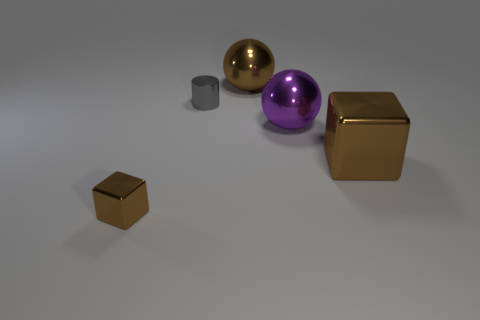Does the brown object left of the gray shiny cylinder have the same material as the large brown object behind the big brown metal block?
Provide a short and direct response. Yes. What is the shape of the big shiny object that is the same color as the large metallic block?
Your answer should be very brief. Sphere. How many brown things are either metal cubes or small cylinders?
Provide a short and direct response. 2. How big is the gray cylinder?
Keep it short and to the point. Small. Is the number of large metallic things behind the small gray cylinder greater than the number of cyan cylinders?
Offer a terse response. Yes. How many large balls are to the left of the small gray thing?
Provide a short and direct response. 0. Are there any red metal cylinders that have the same size as the gray metal object?
Offer a very short reply. No. What color is the other metal thing that is the same shape as the large purple object?
Offer a terse response. Brown. Do the sphere that is right of the brown metallic sphere and the metallic block on the right side of the purple object have the same size?
Give a very brief answer. Yes. Are there any other objects that have the same shape as the tiny brown thing?
Offer a terse response. Yes. 